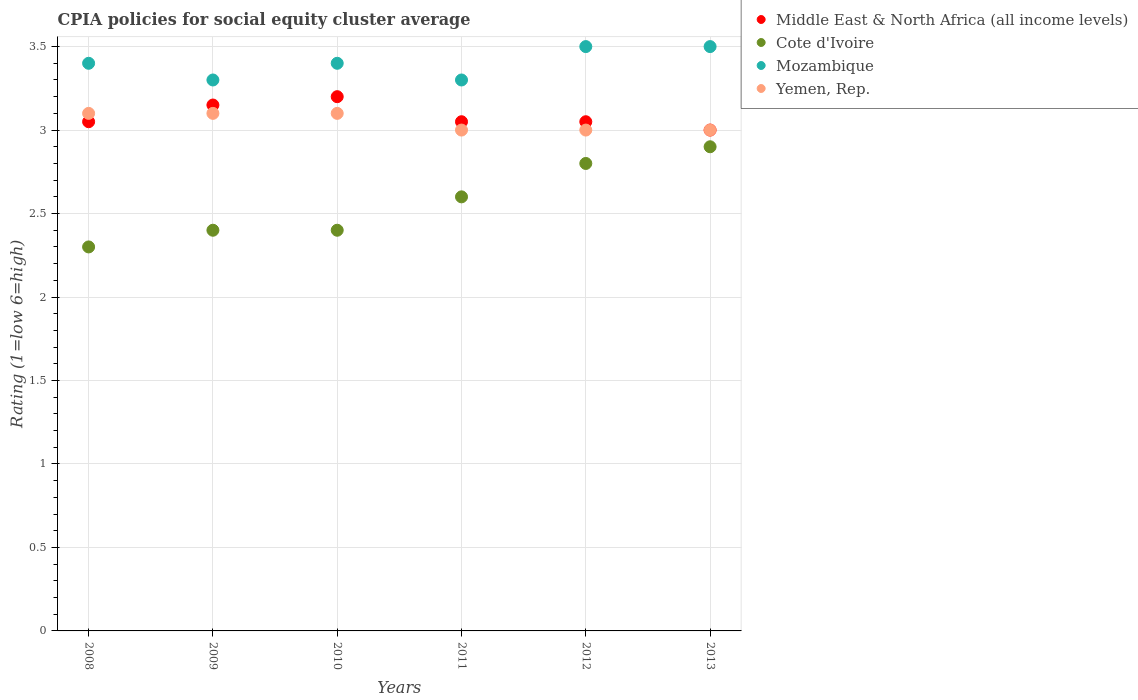Is the number of dotlines equal to the number of legend labels?
Your answer should be very brief. Yes. What is the CPIA rating in Yemen, Rep. in 2011?
Offer a terse response. 3. Across all years, what is the maximum CPIA rating in Middle East & North Africa (all income levels)?
Ensure brevity in your answer.  3.2. In which year was the CPIA rating in Middle East & North Africa (all income levels) minimum?
Offer a very short reply. 2013. What is the total CPIA rating in Mozambique in the graph?
Offer a terse response. 20.4. What is the difference between the CPIA rating in Cote d'Ivoire in 2008 and that in 2010?
Offer a very short reply. -0.1. What is the difference between the CPIA rating in Cote d'Ivoire in 2008 and the CPIA rating in Yemen, Rep. in 2009?
Your answer should be very brief. -0.8. What is the average CPIA rating in Yemen, Rep. per year?
Offer a terse response. 3.05. In the year 2012, what is the difference between the CPIA rating in Middle East & North Africa (all income levels) and CPIA rating in Yemen, Rep.?
Provide a short and direct response. 0.05. In how many years, is the CPIA rating in Yemen, Rep. greater than 3.1?
Your response must be concise. 0. What is the ratio of the CPIA rating in Middle East & North Africa (all income levels) in 2009 to that in 2010?
Your answer should be compact. 0.98. What is the difference between the highest and the second highest CPIA rating in Yemen, Rep.?
Provide a short and direct response. 0. What is the difference between the highest and the lowest CPIA rating in Mozambique?
Provide a succinct answer. 0.2. In how many years, is the CPIA rating in Cote d'Ivoire greater than the average CPIA rating in Cote d'Ivoire taken over all years?
Keep it short and to the point. 3. Is it the case that in every year, the sum of the CPIA rating in Yemen, Rep. and CPIA rating in Middle East & North Africa (all income levels)  is greater than the sum of CPIA rating in Cote d'Ivoire and CPIA rating in Mozambique?
Keep it short and to the point. No. Are the values on the major ticks of Y-axis written in scientific E-notation?
Your response must be concise. No. Does the graph contain grids?
Ensure brevity in your answer.  Yes. Where does the legend appear in the graph?
Provide a succinct answer. Top right. How are the legend labels stacked?
Offer a terse response. Vertical. What is the title of the graph?
Provide a succinct answer. CPIA policies for social equity cluster average. Does "Gambia, The" appear as one of the legend labels in the graph?
Keep it short and to the point. No. What is the label or title of the X-axis?
Make the answer very short. Years. What is the label or title of the Y-axis?
Your response must be concise. Rating (1=low 6=high). What is the Rating (1=low 6=high) in Middle East & North Africa (all income levels) in 2008?
Offer a very short reply. 3.05. What is the Rating (1=low 6=high) of Cote d'Ivoire in 2008?
Give a very brief answer. 2.3. What is the Rating (1=low 6=high) of Mozambique in 2008?
Your response must be concise. 3.4. What is the Rating (1=low 6=high) in Yemen, Rep. in 2008?
Your response must be concise. 3.1. What is the Rating (1=low 6=high) in Middle East & North Africa (all income levels) in 2009?
Ensure brevity in your answer.  3.15. What is the Rating (1=low 6=high) of Cote d'Ivoire in 2010?
Give a very brief answer. 2.4. What is the Rating (1=low 6=high) of Mozambique in 2010?
Keep it short and to the point. 3.4. What is the Rating (1=low 6=high) of Yemen, Rep. in 2010?
Your response must be concise. 3.1. What is the Rating (1=low 6=high) in Middle East & North Africa (all income levels) in 2011?
Offer a terse response. 3.05. What is the Rating (1=low 6=high) in Cote d'Ivoire in 2011?
Your answer should be very brief. 2.6. What is the Rating (1=low 6=high) in Yemen, Rep. in 2011?
Your answer should be compact. 3. What is the Rating (1=low 6=high) of Middle East & North Africa (all income levels) in 2012?
Make the answer very short. 3.05. What is the Rating (1=low 6=high) in Yemen, Rep. in 2012?
Offer a terse response. 3. What is the Rating (1=low 6=high) of Middle East & North Africa (all income levels) in 2013?
Your answer should be very brief. 3. Across all years, what is the maximum Rating (1=low 6=high) in Middle East & North Africa (all income levels)?
Ensure brevity in your answer.  3.2. Across all years, what is the maximum Rating (1=low 6=high) of Cote d'Ivoire?
Your answer should be compact. 2.9. Across all years, what is the maximum Rating (1=low 6=high) of Mozambique?
Give a very brief answer. 3.5. What is the total Rating (1=low 6=high) in Cote d'Ivoire in the graph?
Provide a succinct answer. 15.4. What is the total Rating (1=low 6=high) of Mozambique in the graph?
Your answer should be very brief. 20.4. What is the difference between the Rating (1=low 6=high) in Middle East & North Africa (all income levels) in 2008 and that in 2009?
Keep it short and to the point. -0.1. What is the difference between the Rating (1=low 6=high) in Cote d'Ivoire in 2008 and that in 2009?
Provide a short and direct response. -0.1. What is the difference between the Rating (1=low 6=high) in Mozambique in 2008 and that in 2009?
Offer a terse response. 0.1. What is the difference between the Rating (1=low 6=high) in Yemen, Rep. in 2008 and that in 2009?
Ensure brevity in your answer.  0. What is the difference between the Rating (1=low 6=high) of Cote d'Ivoire in 2008 and that in 2010?
Your answer should be compact. -0.1. What is the difference between the Rating (1=low 6=high) in Middle East & North Africa (all income levels) in 2008 and that in 2011?
Keep it short and to the point. 0. What is the difference between the Rating (1=low 6=high) in Cote d'Ivoire in 2008 and that in 2011?
Provide a short and direct response. -0.3. What is the difference between the Rating (1=low 6=high) of Mozambique in 2008 and that in 2011?
Keep it short and to the point. 0.1. What is the difference between the Rating (1=low 6=high) in Yemen, Rep. in 2008 and that in 2011?
Make the answer very short. 0.1. What is the difference between the Rating (1=low 6=high) in Yemen, Rep. in 2008 and that in 2012?
Offer a very short reply. 0.1. What is the difference between the Rating (1=low 6=high) in Yemen, Rep. in 2008 and that in 2013?
Your response must be concise. 0.1. What is the difference between the Rating (1=low 6=high) of Mozambique in 2009 and that in 2010?
Your answer should be very brief. -0.1. What is the difference between the Rating (1=low 6=high) of Mozambique in 2009 and that in 2011?
Provide a short and direct response. 0. What is the difference between the Rating (1=low 6=high) in Yemen, Rep. in 2009 and that in 2012?
Offer a terse response. 0.1. What is the difference between the Rating (1=low 6=high) of Cote d'Ivoire in 2010 and that in 2011?
Give a very brief answer. -0.2. What is the difference between the Rating (1=low 6=high) in Mozambique in 2010 and that in 2011?
Offer a terse response. 0.1. What is the difference between the Rating (1=low 6=high) of Middle East & North Africa (all income levels) in 2010 and that in 2012?
Provide a succinct answer. 0.15. What is the difference between the Rating (1=low 6=high) in Cote d'Ivoire in 2010 and that in 2012?
Provide a succinct answer. -0.4. What is the difference between the Rating (1=low 6=high) in Yemen, Rep. in 2010 and that in 2012?
Provide a succinct answer. 0.1. What is the difference between the Rating (1=low 6=high) of Cote d'Ivoire in 2010 and that in 2013?
Provide a short and direct response. -0.5. What is the difference between the Rating (1=low 6=high) of Mozambique in 2010 and that in 2013?
Your answer should be compact. -0.1. What is the difference between the Rating (1=low 6=high) of Middle East & North Africa (all income levels) in 2011 and that in 2012?
Give a very brief answer. 0. What is the difference between the Rating (1=low 6=high) of Mozambique in 2011 and that in 2012?
Your answer should be compact. -0.2. What is the difference between the Rating (1=low 6=high) in Cote d'Ivoire in 2011 and that in 2013?
Ensure brevity in your answer.  -0.3. What is the difference between the Rating (1=low 6=high) of Middle East & North Africa (all income levels) in 2012 and that in 2013?
Make the answer very short. 0.05. What is the difference between the Rating (1=low 6=high) of Cote d'Ivoire in 2012 and that in 2013?
Your answer should be compact. -0.1. What is the difference between the Rating (1=low 6=high) in Yemen, Rep. in 2012 and that in 2013?
Keep it short and to the point. 0. What is the difference between the Rating (1=low 6=high) of Middle East & North Africa (all income levels) in 2008 and the Rating (1=low 6=high) of Cote d'Ivoire in 2009?
Offer a very short reply. 0.65. What is the difference between the Rating (1=low 6=high) in Middle East & North Africa (all income levels) in 2008 and the Rating (1=low 6=high) in Mozambique in 2009?
Offer a terse response. -0.25. What is the difference between the Rating (1=low 6=high) in Mozambique in 2008 and the Rating (1=low 6=high) in Yemen, Rep. in 2009?
Make the answer very short. 0.3. What is the difference between the Rating (1=low 6=high) of Middle East & North Africa (all income levels) in 2008 and the Rating (1=low 6=high) of Cote d'Ivoire in 2010?
Make the answer very short. 0.65. What is the difference between the Rating (1=low 6=high) in Middle East & North Africa (all income levels) in 2008 and the Rating (1=low 6=high) in Mozambique in 2010?
Your answer should be very brief. -0.35. What is the difference between the Rating (1=low 6=high) of Middle East & North Africa (all income levels) in 2008 and the Rating (1=low 6=high) of Cote d'Ivoire in 2011?
Offer a terse response. 0.45. What is the difference between the Rating (1=low 6=high) of Cote d'Ivoire in 2008 and the Rating (1=low 6=high) of Mozambique in 2011?
Your answer should be very brief. -1. What is the difference between the Rating (1=low 6=high) of Cote d'Ivoire in 2008 and the Rating (1=low 6=high) of Yemen, Rep. in 2011?
Your answer should be compact. -0.7. What is the difference between the Rating (1=low 6=high) in Mozambique in 2008 and the Rating (1=low 6=high) in Yemen, Rep. in 2011?
Keep it short and to the point. 0.4. What is the difference between the Rating (1=low 6=high) of Middle East & North Africa (all income levels) in 2008 and the Rating (1=low 6=high) of Mozambique in 2012?
Ensure brevity in your answer.  -0.45. What is the difference between the Rating (1=low 6=high) in Middle East & North Africa (all income levels) in 2008 and the Rating (1=low 6=high) in Yemen, Rep. in 2012?
Give a very brief answer. 0.05. What is the difference between the Rating (1=low 6=high) in Cote d'Ivoire in 2008 and the Rating (1=low 6=high) in Mozambique in 2012?
Keep it short and to the point. -1.2. What is the difference between the Rating (1=low 6=high) in Cote d'Ivoire in 2008 and the Rating (1=low 6=high) in Yemen, Rep. in 2012?
Your response must be concise. -0.7. What is the difference between the Rating (1=low 6=high) in Mozambique in 2008 and the Rating (1=low 6=high) in Yemen, Rep. in 2012?
Offer a very short reply. 0.4. What is the difference between the Rating (1=low 6=high) in Middle East & North Africa (all income levels) in 2008 and the Rating (1=low 6=high) in Mozambique in 2013?
Your response must be concise. -0.45. What is the difference between the Rating (1=low 6=high) in Middle East & North Africa (all income levels) in 2008 and the Rating (1=low 6=high) in Yemen, Rep. in 2013?
Your answer should be compact. 0.05. What is the difference between the Rating (1=low 6=high) of Cote d'Ivoire in 2008 and the Rating (1=low 6=high) of Mozambique in 2013?
Ensure brevity in your answer.  -1.2. What is the difference between the Rating (1=low 6=high) in Middle East & North Africa (all income levels) in 2009 and the Rating (1=low 6=high) in Mozambique in 2010?
Provide a succinct answer. -0.25. What is the difference between the Rating (1=low 6=high) in Middle East & North Africa (all income levels) in 2009 and the Rating (1=low 6=high) in Cote d'Ivoire in 2011?
Your response must be concise. 0.55. What is the difference between the Rating (1=low 6=high) of Middle East & North Africa (all income levels) in 2009 and the Rating (1=low 6=high) of Yemen, Rep. in 2011?
Ensure brevity in your answer.  0.15. What is the difference between the Rating (1=low 6=high) in Cote d'Ivoire in 2009 and the Rating (1=low 6=high) in Mozambique in 2011?
Your answer should be compact. -0.9. What is the difference between the Rating (1=low 6=high) in Middle East & North Africa (all income levels) in 2009 and the Rating (1=low 6=high) in Cote d'Ivoire in 2012?
Your response must be concise. 0.35. What is the difference between the Rating (1=low 6=high) in Middle East & North Africa (all income levels) in 2009 and the Rating (1=low 6=high) in Mozambique in 2012?
Provide a succinct answer. -0.35. What is the difference between the Rating (1=low 6=high) in Middle East & North Africa (all income levels) in 2009 and the Rating (1=low 6=high) in Yemen, Rep. in 2012?
Give a very brief answer. 0.15. What is the difference between the Rating (1=low 6=high) in Mozambique in 2009 and the Rating (1=low 6=high) in Yemen, Rep. in 2012?
Your answer should be compact. 0.3. What is the difference between the Rating (1=low 6=high) in Middle East & North Africa (all income levels) in 2009 and the Rating (1=low 6=high) in Cote d'Ivoire in 2013?
Give a very brief answer. 0.25. What is the difference between the Rating (1=low 6=high) in Middle East & North Africa (all income levels) in 2009 and the Rating (1=low 6=high) in Mozambique in 2013?
Give a very brief answer. -0.35. What is the difference between the Rating (1=low 6=high) in Cote d'Ivoire in 2009 and the Rating (1=low 6=high) in Yemen, Rep. in 2013?
Your answer should be compact. -0.6. What is the difference between the Rating (1=low 6=high) in Middle East & North Africa (all income levels) in 2010 and the Rating (1=low 6=high) in Cote d'Ivoire in 2011?
Your answer should be compact. 0.6. What is the difference between the Rating (1=low 6=high) of Cote d'Ivoire in 2010 and the Rating (1=low 6=high) of Yemen, Rep. in 2011?
Your answer should be very brief. -0.6. What is the difference between the Rating (1=low 6=high) of Middle East & North Africa (all income levels) in 2010 and the Rating (1=low 6=high) of Cote d'Ivoire in 2012?
Offer a very short reply. 0.4. What is the difference between the Rating (1=low 6=high) in Middle East & North Africa (all income levels) in 2010 and the Rating (1=low 6=high) in Mozambique in 2012?
Offer a very short reply. -0.3. What is the difference between the Rating (1=low 6=high) in Cote d'Ivoire in 2010 and the Rating (1=low 6=high) in Mozambique in 2012?
Provide a succinct answer. -1.1. What is the difference between the Rating (1=low 6=high) of Mozambique in 2010 and the Rating (1=low 6=high) of Yemen, Rep. in 2012?
Offer a terse response. 0.4. What is the difference between the Rating (1=low 6=high) of Middle East & North Africa (all income levels) in 2010 and the Rating (1=low 6=high) of Cote d'Ivoire in 2013?
Keep it short and to the point. 0.3. What is the difference between the Rating (1=low 6=high) of Middle East & North Africa (all income levels) in 2010 and the Rating (1=low 6=high) of Mozambique in 2013?
Make the answer very short. -0.3. What is the difference between the Rating (1=low 6=high) of Middle East & North Africa (all income levels) in 2010 and the Rating (1=low 6=high) of Yemen, Rep. in 2013?
Give a very brief answer. 0.2. What is the difference between the Rating (1=low 6=high) of Cote d'Ivoire in 2010 and the Rating (1=low 6=high) of Mozambique in 2013?
Provide a succinct answer. -1.1. What is the difference between the Rating (1=low 6=high) of Cote d'Ivoire in 2010 and the Rating (1=low 6=high) of Yemen, Rep. in 2013?
Offer a terse response. -0.6. What is the difference between the Rating (1=low 6=high) in Mozambique in 2010 and the Rating (1=low 6=high) in Yemen, Rep. in 2013?
Your answer should be very brief. 0.4. What is the difference between the Rating (1=low 6=high) of Middle East & North Africa (all income levels) in 2011 and the Rating (1=low 6=high) of Cote d'Ivoire in 2012?
Your response must be concise. 0.25. What is the difference between the Rating (1=low 6=high) of Middle East & North Africa (all income levels) in 2011 and the Rating (1=low 6=high) of Mozambique in 2012?
Provide a short and direct response. -0.45. What is the difference between the Rating (1=low 6=high) of Cote d'Ivoire in 2011 and the Rating (1=low 6=high) of Yemen, Rep. in 2012?
Your response must be concise. -0.4. What is the difference between the Rating (1=low 6=high) in Middle East & North Africa (all income levels) in 2011 and the Rating (1=low 6=high) in Cote d'Ivoire in 2013?
Provide a succinct answer. 0.15. What is the difference between the Rating (1=low 6=high) in Middle East & North Africa (all income levels) in 2011 and the Rating (1=low 6=high) in Mozambique in 2013?
Ensure brevity in your answer.  -0.45. What is the difference between the Rating (1=low 6=high) of Middle East & North Africa (all income levels) in 2011 and the Rating (1=low 6=high) of Yemen, Rep. in 2013?
Offer a terse response. 0.05. What is the difference between the Rating (1=low 6=high) of Mozambique in 2011 and the Rating (1=low 6=high) of Yemen, Rep. in 2013?
Offer a very short reply. 0.3. What is the difference between the Rating (1=low 6=high) of Middle East & North Africa (all income levels) in 2012 and the Rating (1=low 6=high) of Cote d'Ivoire in 2013?
Ensure brevity in your answer.  0.15. What is the difference between the Rating (1=low 6=high) of Middle East & North Africa (all income levels) in 2012 and the Rating (1=low 6=high) of Mozambique in 2013?
Offer a very short reply. -0.45. What is the difference between the Rating (1=low 6=high) in Middle East & North Africa (all income levels) in 2012 and the Rating (1=low 6=high) in Yemen, Rep. in 2013?
Your response must be concise. 0.05. What is the difference between the Rating (1=low 6=high) of Cote d'Ivoire in 2012 and the Rating (1=low 6=high) of Mozambique in 2013?
Your answer should be compact. -0.7. What is the difference between the Rating (1=low 6=high) of Cote d'Ivoire in 2012 and the Rating (1=low 6=high) of Yemen, Rep. in 2013?
Provide a succinct answer. -0.2. What is the difference between the Rating (1=low 6=high) of Mozambique in 2012 and the Rating (1=low 6=high) of Yemen, Rep. in 2013?
Offer a very short reply. 0.5. What is the average Rating (1=low 6=high) in Middle East & North Africa (all income levels) per year?
Your answer should be very brief. 3.08. What is the average Rating (1=low 6=high) of Cote d'Ivoire per year?
Provide a succinct answer. 2.57. What is the average Rating (1=low 6=high) in Mozambique per year?
Provide a short and direct response. 3.4. What is the average Rating (1=low 6=high) in Yemen, Rep. per year?
Keep it short and to the point. 3.05. In the year 2008, what is the difference between the Rating (1=low 6=high) of Middle East & North Africa (all income levels) and Rating (1=low 6=high) of Cote d'Ivoire?
Ensure brevity in your answer.  0.75. In the year 2008, what is the difference between the Rating (1=low 6=high) in Middle East & North Africa (all income levels) and Rating (1=low 6=high) in Mozambique?
Provide a succinct answer. -0.35. In the year 2008, what is the difference between the Rating (1=low 6=high) in Middle East & North Africa (all income levels) and Rating (1=low 6=high) in Yemen, Rep.?
Offer a very short reply. -0.05. In the year 2008, what is the difference between the Rating (1=low 6=high) in Cote d'Ivoire and Rating (1=low 6=high) in Mozambique?
Your answer should be very brief. -1.1. In the year 2009, what is the difference between the Rating (1=low 6=high) in Middle East & North Africa (all income levels) and Rating (1=low 6=high) in Cote d'Ivoire?
Keep it short and to the point. 0.75. In the year 2009, what is the difference between the Rating (1=low 6=high) of Middle East & North Africa (all income levels) and Rating (1=low 6=high) of Mozambique?
Keep it short and to the point. -0.15. In the year 2009, what is the difference between the Rating (1=low 6=high) in Cote d'Ivoire and Rating (1=low 6=high) in Mozambique?
Make the answer very short. -0.9. In the year 2010, what is the difference between the Rating (1=low 6=high) in Middle East & North Africa (all income levels) and Rating (1=low 6=high) in Cote d'Ivoire?
Ensure brevity in your answer.  0.8. In the year 2010, what is the difference between the Rating (1=low 6=high) in Middle East & North Africa (all income levels) and Rating (1=low 6=high) in Yemen, Rep.?
Your answer should be compact. 0.1. In the year 2011, what is the difference between the Rating (1=low 6=high) of Middle East & North Africa (all income levels) and Rating (1=low 6=high) of Cote d'Ivoire?
Make the answer very short. 0.45. In the year 2011, what is the difference between the Rating (1=low 6=high) in Middle East & North Africa (all income levels) and Rating (1=low 6=high) in Mozambique?
Provide a short and direct response. -0.25. In the year 2011, what is the difference between the Rating (1=low 6=high) in Middle East & North Africa (all income levels) and Rating (1=low 6=high) in Yemen, Rep.?
Keep it short and to the point. 0.05. In the year 2011, what is the difference between the Rating (1=low 6=high) in Cote d'Ivoire and Rating (1=low 6=high) in Mozambique?
Provide a succinct answer. -0.7. In the year 2011, what is the difference between the Rating (1=low 6=high) of Cote d'Ivoire and Rating (1=low 6=high) of Yemen, Rep.?
Keep it short and to the point. -0.4. In the year 2012, what is the difference between the Rating (1=low 6=high) of Middle East & North Africa (all income levels) and Rating (1=low 6=high) of Cote d'Ivoire?
Offer a very short reply. 0.25. In the year 2012, what is the difference between the Rating (1=low 6=high) of Middle East & North Africa (all income levels) and Rating (1=low 6=high) of Mozambique?
Keep it short and to the point. -0.45. In the year 2012, what is the difference between the Rating (1=low 6=high) of Middle East & North Africa (all income levels) and Rating (1=low 6=high) of Yemen, Rep.?
Your answer should be compact. 0.05. In the year 2012, what is the difference between the Rating (1=low 6=high) in Cote d'Ivoire and Rating (1=low 6=high) in Mozambique?
Your answer should be compact. -0.7. In the year 2012, what is the difference between the Rating (1=low 6=high) of Cote d'Ivoire and Rating (1=low 6=high) of Yemen, Rep.?
Your answer should be compact. -0.2. In the year 2013, what is the difference between the Rating (1=low 6=high) in Middle East & North Africa (all income levels) and Rating (1=low 6=high) in Cote d'Ivoire?
Your answer should be compact. 0.1. In the year 2013, what is the difference between the Rating (1=low 6=high) of Middle East & North Africa (all income levels) and Rating (1=low 6=high) of Yemen, Rep.?
Your answer should be very brief. 0. In the year 2013, what is the difference between the Rating (1=low 6=high) of Mozambique and Rating (1=low 6=high) of Yemen, Rep.?
Offer a terse response. 0.5. What is the ratio of the Rating (1=low 6=high) of Middle East & North Africa (all income levels) in 2008 to that in 2009?
Ensure brevity in your answer.  0.97. What is the ratio of the Rating (1=low 6=high) of Mozambique in 2008 to that in 2009?
Your answer should be compact. 1.03. What is the ratio of the Rating (1=low 6=high) of Middle East & North Africa (all income levels) in 2008 to that in 2010?
Keep it short and to the point. 0.95. What is the ratio of the Rating (1=low 6=high) in Cote d'Ivoire in 2008 to that in 2010?
Offer a very short reply. 0.96. What is the ratio of the Rating (1=low 6=high) of Yemen, Rep. in 2008 to that in 2010?
Your answer should be very brief. 1. What is the ratio of the Rating (1=low 6=high) of Middle East & North Africa (all income levels) in 2008 to that in 2011?
Offer a terse response. 1. What is the ratio of the Rating (1=low 6=high) in Cote d'Ivoire in 2008 to that in 2011?
Provide a succinct answer. 0.88. What is the ratio of the Rating (1=low 6=high) in Mozambique in 2008 to that in 2011?
Your answer should be very brief. 1.03. What is the ratio of the Rating (1=low 6=high) in Middle East & North Africa (all income levels) in 2008 to that in 2012?
Offer a very short reply. 1. What is the ratio of the Rating (1=low 6=high) of Cote d'Ivoire in 2008 to that in 2012?
Provide a short and direct response. 0.82. What is the ratio of the Rating (1=low 6=high) of Mozambique in 2008 to that in 2012?
Ensure brevity in your answer.  0.97. What is the ratio of the Rating (1=low 6=high) of Middle East & North Africa (all income levels) in 2008 to that in 2013?
Ensure brevity in your answer.  1.02. What is the ratio of the Rating (1=low 6=high) of Cote d'Ivoire in 2008 to that in 2013?
Provide a succinct answer. 0.79. What is the ratio of the Rating (1=low 6=high) of Mozambique in 2008 to that in 2013?
Make the answer very short. 0.97. What is the ratio of the Rating (1=low 6=high) in Middle East & North Africa (all income levels) in 2009 to that in 2010?
Make the answer very short. 0.98. What is the ratio of the Rating (1=low 6=high) of Mozambique in 2009 to that in 2010?
Provide a succinct answer. 0.97. What is the ratio of the Rating (1=low 6=high) of Middle East & North Africa (all income levels) in 2009 to that in 2011?
Make the answer very short. 1.03. What is the ratio of the Rating (1=low 6=high) of Cote d'Ivoire in 2009 to that in 2011?
Provide a short and direct response. 0.92. What is the ratio of the Rating (1=low 6=high) in Mozambique in 2009 to that in 2011?
Keep it short and to the point. 1. What is the ratio of the Rating (1=low 6=high) of Yemen, Rep. in 2009 to that in 2011?
Provide a succinct answer. 1.03. What is the ratio of the Rating (1=low 6=high) in Middle East & North Africa (all income levels) in 2009 to that in 2012?
Ensure brevity in your answer.  1.03. What is the ratio of the Rating (1=low 6=high) of Cote d'Ivoire in 2009 to that in 2012?
Make the answer very short. 0.86. What is the ratio of the Rating (1=low 6=high) in Mozambique in 2009 to that in 2012?
Offer a very short reply. 0.94. What is the ratio of the Rating (1=low 6=high) of Cote d'Ivoire in 2009 to that in 2013?
Your answer should be very brief. 0.83. What is the ratio of the Rating (1=low 6=high) of Mozambique in 2009 to that in 2013?
Offer a very short reply. 0.94. What is the ratio of the Rating (1=low 6=high) of Middle East & North Africa (all income levels) in 2010 to that in 2011?
Offer a terse response. 1.05. What is the ratio of the Rating (1=low 6=high) in Cote d'Ivoire in 2010 to that in 2011?
Provide a short and direct response. 0.92. What is the ratio of the Rating (1=low 6=high) in Mozambique in 2010 to that in 2011?
Your response must be concise. 1.03. What is the ratio of the Rating (1=low 6=high) in Middle East & North Africa (all income levels) in 2010 to that in 2012?
Your answer should be very brief. 1.05. What is the ratio of the Rating (1=low 6=high) of Mozambique in 2010 to that in 2012?
Provide a succinct answer. 0.97. What is the ratio of the Rating (1=low 6=high) of Yemen, Rep. in 2010 to that in 2012?
Offer a terse response. 1.03. What is the ratio of the Rating (1=low 6=high) of Middle East & North Africa (all income levels) in 2010 to that in 2013?
Keep it short and to the point. 1.07. What is the ratio of the Rating (1=low 6=high) of Cote d'Ivoire in 2010 to that in 2013?
Keep it short and to the point. 0.83. What is the ratio of the Rating (1=low 6=high) in Mozambique in 2010 to that in 2013?
Your answer should be compact. 0.97. What is the ratio of the Rating (1=low 6=high) in Cote d'Ivoire in 2011 to that in 2012?
Make the answer very short. 0.93. What is the ratio of the Rating (1=low 6=high) of Mozambique in 2011 to that in 2012?
Your response must be concise. 0.94. What is the ratio of the Rating (1=low 6=high) in Yemen, Rep. in 2011 to that in 2012?
Your answer should be very brief. 1. What is the ratio of the Rating (1=low 6=high) of Middle East & North Africa (all income levels) in 2011 to that in 2013?
Your answer should be compact. 1.02. What is the ratio of the Rating (1=low 6=high) in Cote d'Ivoire in 2011 to that in 2013?
Make the answer very short. 0.9. What is the ratio of the Rating (1=low 6=high) in Mozambique in 2011 to that in 2013?
Provide a short and direct response. 0.94. What is the ratio of the Rating (1=low 6=high) of Yemen, Rep. in 2011 to that in 2013?
Offer a terse response. 1. What is the ratio of the Rating (1=low 6=high) of Middle East & North Africa (all income levels) in 2012 to that in 2013?
Your answer should be compact. 1.02. What is the ratio of the Rating (1=low 6=high) in Cote d'Ivoire in 2012 to that in 2013?
Offer a terse response. 0.97. What is the ratio of the Rating (1=low 6=high) in Mozambique in 2012 to that in 2013?
Your response must be concise. 1. What is the difference between the highest and the second highest Rating (1=low 6=high) in Mozambique?
Make the answer very short. 0. What is the difference between the highest and the lowest Rating (1=low 6=high) in Middle East & North Africa (all income levels)?
Keep it short and to the point. 0.2. What is the difference between the highest and the lowest Rating (1=low 6=high) of Cote d'Ivoire?
Offer a terse response. 0.6. 